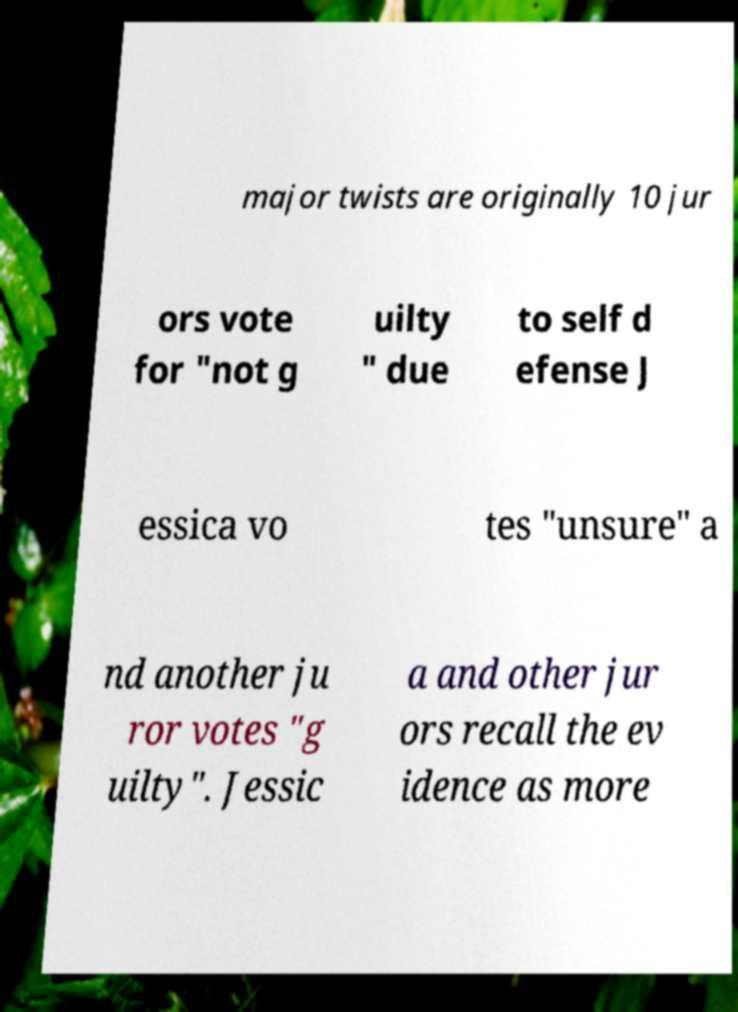Can you accurately transcribe the text from the provided image for me? major twists are originally 10 jur ors vote for "not g uilty " due to self d efense J essica vo tes "unsure" a nd another ju ror votes "g uilty". Jessic a and other jur ors recall the ev idence as more 